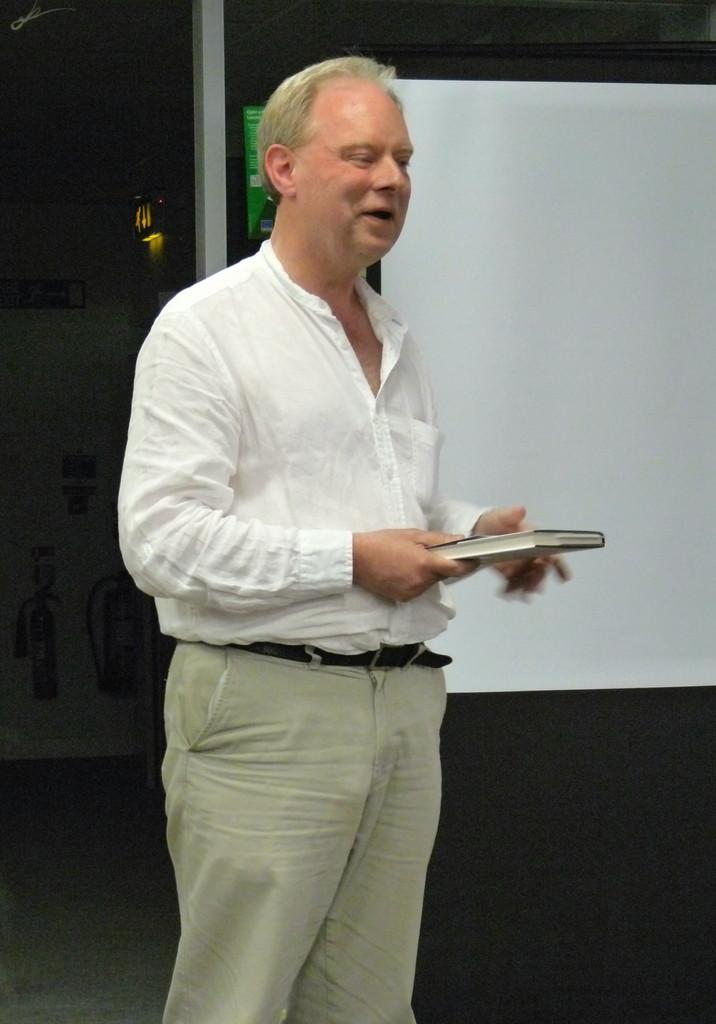What is the main subject of the image? There is a person in the image. What is the person wearing? The person is wearing a white shirt. What is the person holding in the image? The person is holding a book. Can you describe the background of the image? The background of the image is dark. What can be seen on the right side of the image? There is a white board on the right side of the image. What type of fruit is being sliced on the white board in the image? There is no fruit present in the image, and no slicing is taking place on the white board. 